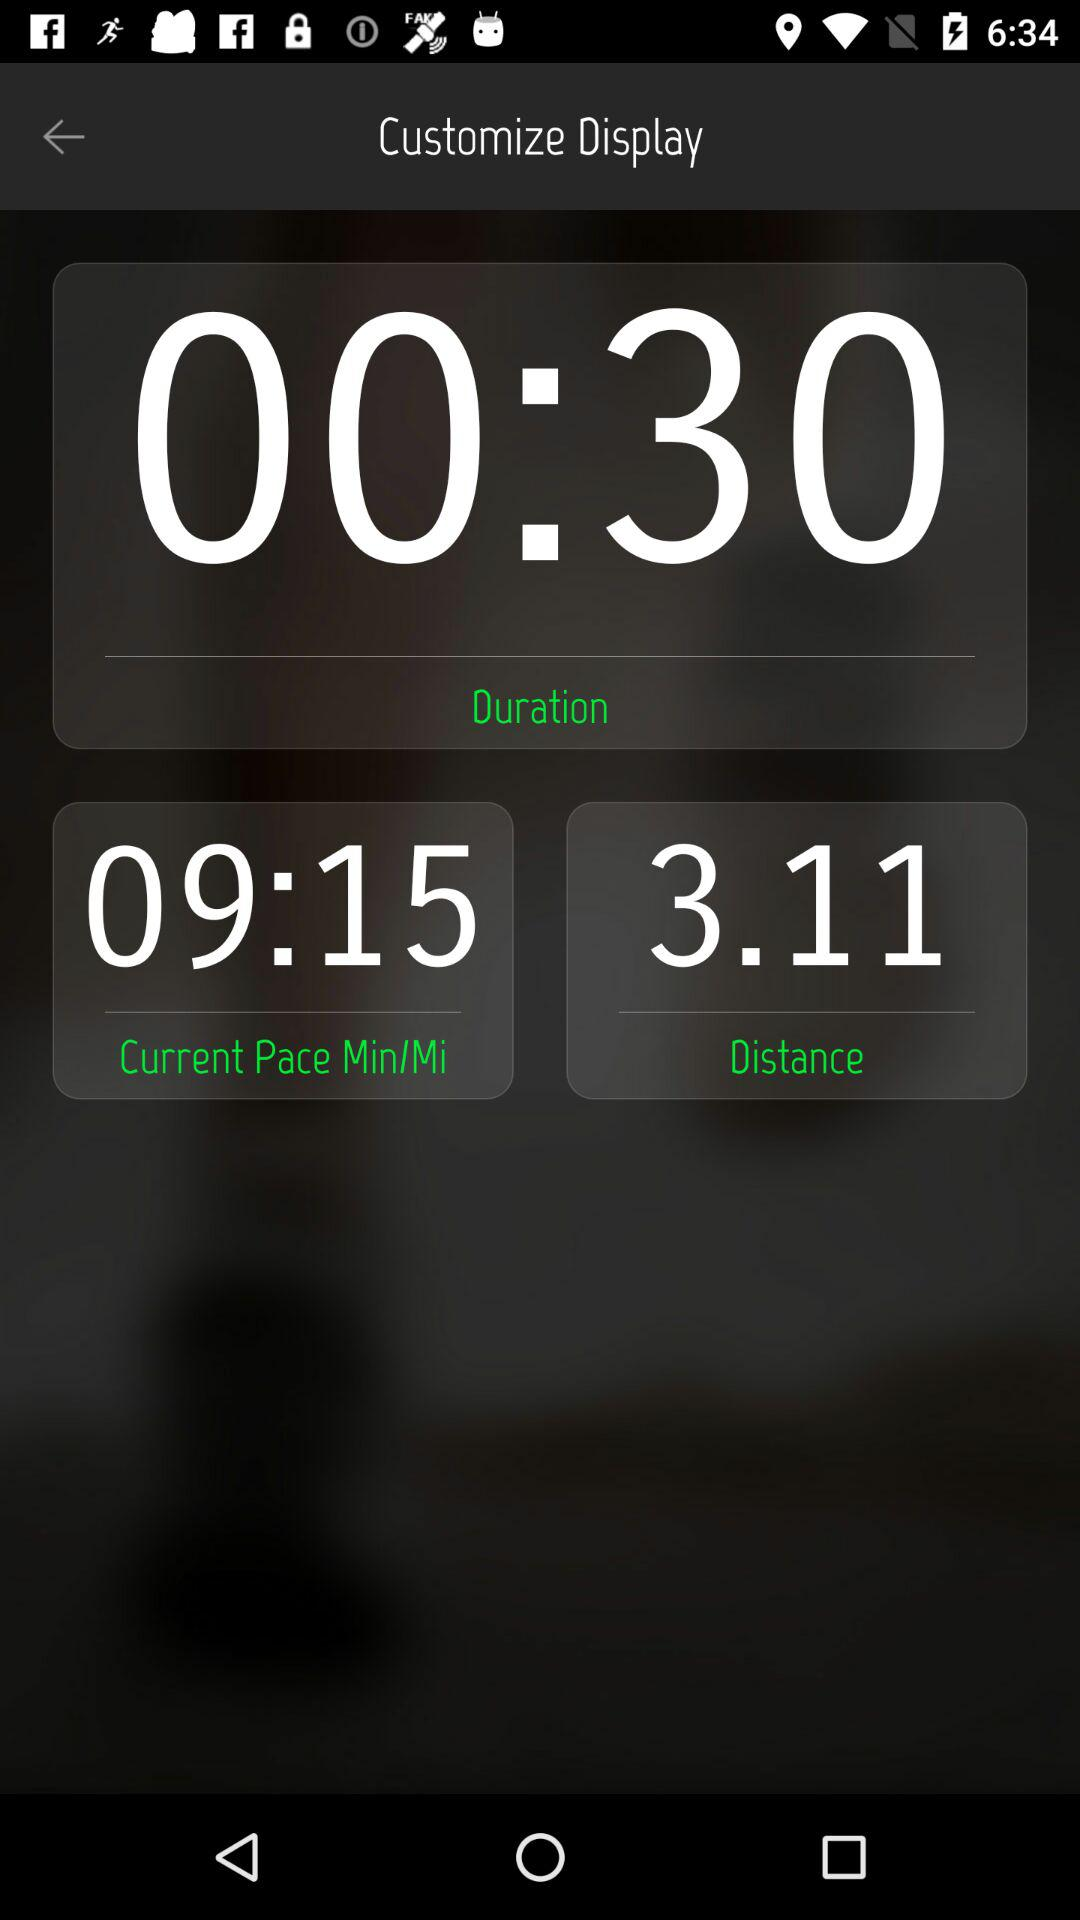What is the time duration? The time duration is 30 seconds. 